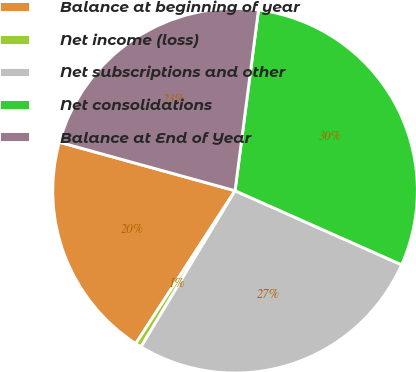Convert chart to OTSL. <chart><loc_0><loc_0><loc_500><loc_500><pie_chart><fcel>Balance at beginning of year<fcel>Net income (loss)<fcel>Net subscriptions and other<fcel>Net consolidations<fcel>Balance at End of Year<nl><fcel>20.12%<fcel>0.54%<fcel>26.97%<fcel>29.61%<fcel>22.76%<nl></chart> 